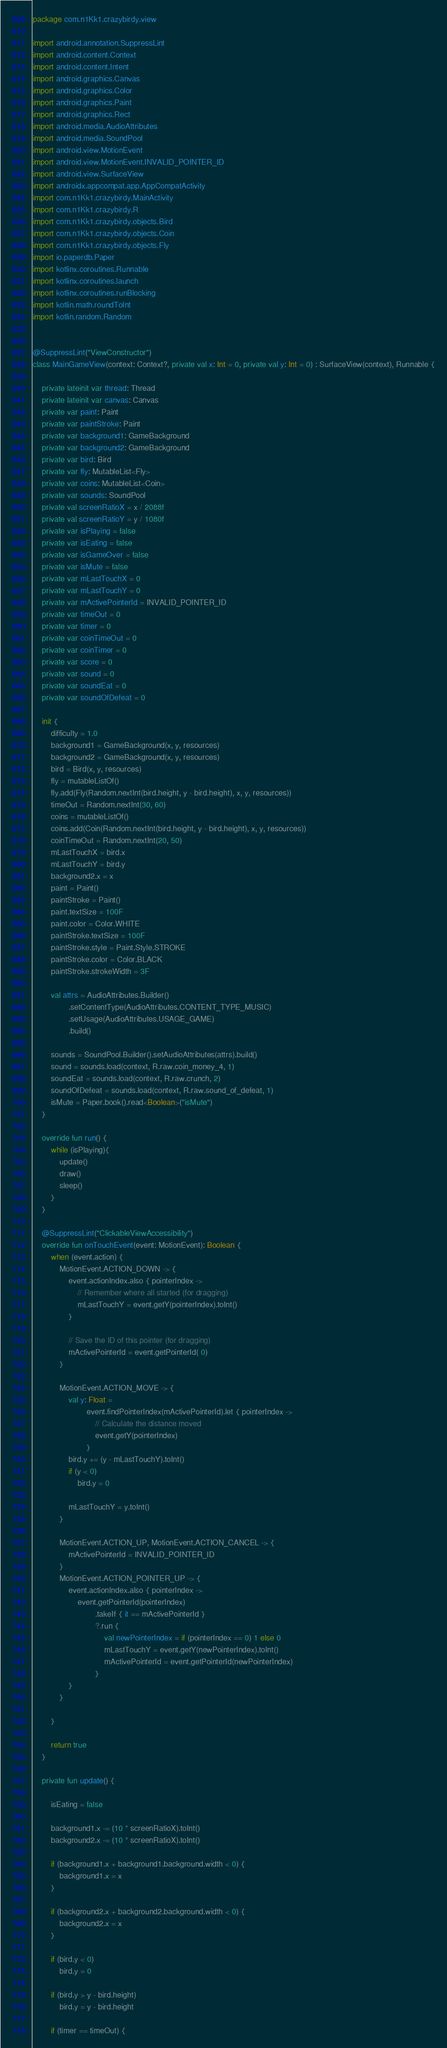Convert code to text. <code><loc_0><loc_0><loc_500><loc_500><_Kotlin_>package com.n1Kk1.crazybirdy.view

import android.annotation.SuppressLint
import android.content.Context
import android.content.Intent
import android.graphics.Canvas
import android.graphics.Color
import android.graphics.Paint
import android.graphics.Rect
import android.media.AudioAttributes
import android.media.SoundPool
import android.view.MotionEvent
import android.view.MotionEvent.INVALID_POINTER_ID
import android.view.SurfaceView
import androidx.appcompat.app.AppCompatActivity
import com.n1Kk1.crazybirdy.MainActivity
import com.n1Kk1.crazybirdy.R
import com.n1Kk1.crazybirdy.objects.Bird
import com.n1Kk1.crazybirdy.objects.Coin
import com.n1Kk1.crazybirdy.objects.Fly
import io.paperdb.Paper
import kotlinx.coroutines.Runnable
import kotlinx.coroutines.launch
import kotlinx.coroutines.runBlocking
import kotlin.math.roundToInt
import kotlin.random.Random


@SuppressLint("ViewConstructor")
class MainGameView(context: Context?, private val x: Int = 0, private val y: Int = 0) : SurfaceView(context), Runnable {

    private lateinit var thread: Thread
    private lateinit var canvas: Canvas
    private var paint: Paint
    private var paintStroke: Paint
    private var background1: GameBackground
    private var background2: GameBackground
    private var bird: Bird
    private var fly: MutableList<Fly>
    private var coins: MutableList<Coin>
    private var sounds: SoundPool
    private val screenRatioX = x / 2088f
    private val screenRatioY = y / 1080f
    private var isPlaying = false
    private var isEating = false
    private var isGameOver = false
    private var isMute = false
    private var mLastTouchX = 0
    private var mLastTouchY = 0
    private var mActivePointerId = INVALID_POINTER_ID
    private var timeOut = 0
    private var timer = 0
    private var coinTimeOut = 0
    private var coinTimer = 0
    private var score = 0
    private var sound = 0
    private var soundEat = 0
    private var soundOfDefeat = 0

    init {
        difficulty = 1.0
        background1 = GameBackground(x, y, resources)
        background2 = GameBackground(x, y, resources)
        bird = Bird(x, y, resources)
        fly = mutableListOf()
        fly.add(Fly(Random.nextInt(bird.height, y - bird.height), x, y, resources))
        timeOut = Random.nextInt(30, 60)
        coins = mutableListOf()
        coins.add(Coin(Random.nextInt(bird.height, y - bird.height), x, y, resources))
        coinTimeOut = Random.nextInt(20, 50)
        mLastTouchX = bird.x
        mLastTouchY = bird.y
        background2.x = x
        paint = Paint()
        paintStroke = Paint()
        paint.textSize = 100F
        paint.color = Color.WHITE
        paintStroke.textSize = 100F
        paintStroke.style = Paint.Style.STROKE
        paintStroke.color = Color.BLACK
        paintStroke.strokeWidth = 3F

        val attrs = AudioAttributes.Builder()
                .setContentType(AudioAttributes.CONTENT_TYPE_MUSIC)
                .setUsage(AudioAttributes.USAGE_GAME)
                .build()

        sounds = SoundPool.Builder().setAudioAttributes(attrs).build()
        sound = sounds.load(context, R.raw.coin_money_4, 1)
        soundEat = sounds.load(context, R.raw.crunch, 2)
        soundOfDefeat = sounds.load(context, R.raw.sound_of_defeat, 1)
        isMute = Paper.book().read<Boolean>("isMute")
    }

    override fun run() {
        while (isPlaying){
            update()
            draw()
            sleep()
        }
    }

    @SuppressLint("ClickableViewAccessibility")
    override fun onTouchEvent(event: MotionEvent): Boolean {
        when (event.action) {
            MotionEvent.ACTION_DOWN -> {
                event.actionIndex.also { pointerIndex ->
                    // Remember where all started (for dragging)
                    mLastTouchY = event.getY(pointerIndex).toInt()
                }

                // Save the ID of this pointer (for dragging)
                mActivePointerId = event.getPointerId( 0)
            }

            MotionEvent.ACTION_MOVE -> {
                val y: Float =
                        event.findPointerIndex(mActivePointerId).let { pointerIndex ->
                            // Calculate the distance moved
                            event.getY(pointerIndex)
                        }
                bird.y += (y - mLastTouchY).toInt()
                if (y < 0)
                    bird.y = 0

                mLastTouchY = y.toInt()
            }

            MotionEvent.ACTION_UP, MotionEvent.ACTION_CANCEL -> {
                mActivePointerId = INVALID_POINTER_ID
            }
            MotionEvent.ACTION_POINTER_UP -> {
                event.actionIndex.also { pointerIndex ->
                    event.getPointerId(pointerIndex)
                            .takeIf { it == mActivePointerId }
                            ?.run {
                                val newPointerIndex = if (pointerIndex == 0) 1 else 0
                                mLastTouchY = event.getY(newPointerIndex).toInt()
                                mActivePointerId = event.getPointerId(newPointerIndex)
                            }
                }
            }

        }

        return true
    }

    private fun update() {

        isEating = false

        background1.x -= (10 * screenRatioX).toInt()
        background2.x -= (10 * screenRatioX).toInt()

        if (background1.x + background1.background.width < 0) {
            background1.x = x
        }

        if (background2.x + background2.background.width < 0) {
            background2.x = x
        }

        if (bird.y < 0)
            bird.y = 0

        if (bird.y > y - bird.height)
            bird.y = y - bird.height

        if (timer == timeOut) {</code> 